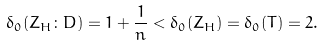<formula> <loc_0><loc_0><loc_500><loc_500>\delta _ { 0 } ( Z _ { H } \colon D ) = 1 + \frac { 1 } { n } < \delta _ { 0 } ( Z _ { H } ) = \delta _ { 0 } ( T ) = 2 .</formula> 